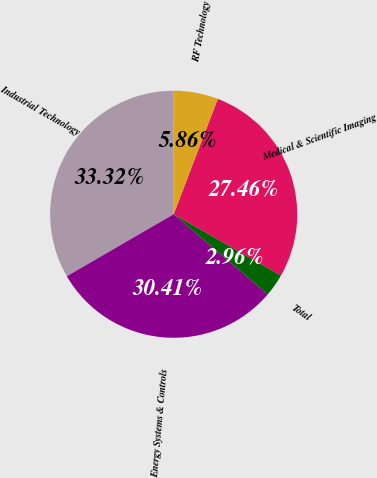Convert chart. <chart><loc_0><loc_0><loc_500><loc_500><pie_chart><fcel>Medical & Scientific Imaging<fcel>RF Technology<fcel>Industrial Technology<fcel>Energy Systems & Controls<fcel>Total<nl><fcel>27.46%<fcel>5.86%<fcel>33.32%<fcel>30.41%<fcel>2.96%<nl></chart> 